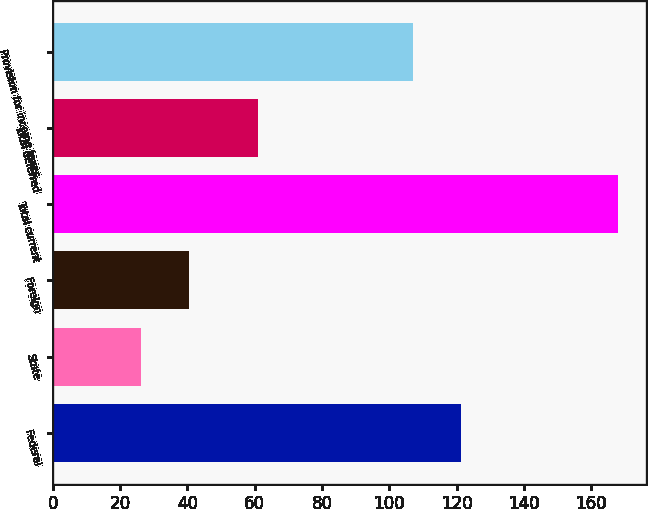<chart> <loc_0><loc_0><loc_500><loc_500><bar_chart><fcel>Federal<fcel>State<fcel>Foreign<fcel>Total current<fcel>Total deferred<fcel>Provision for income taxes<nl><fcel>121.17<fcel>26.2<fcel>40.37<fcel>167.9<fcel>60.9<fcel>107<nl></chart> 